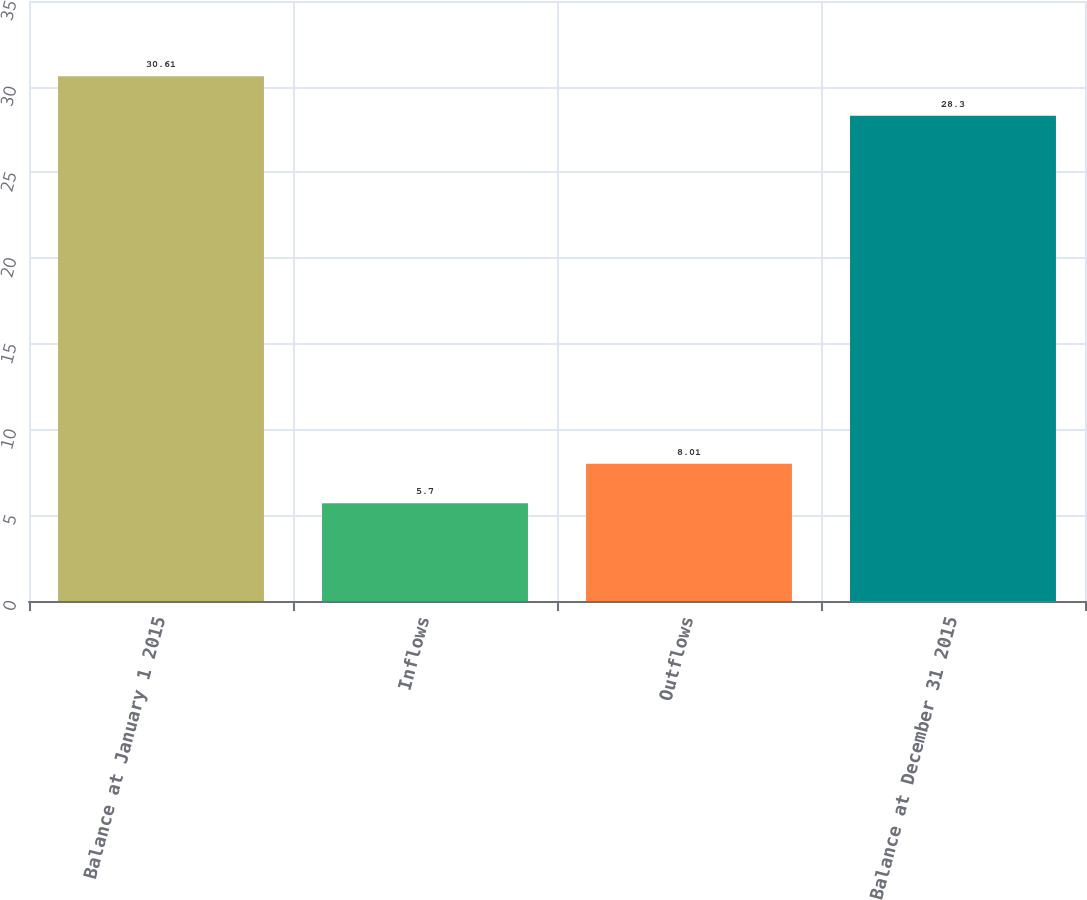Convert chart to OTSL. <chart><loc_0><loc_0><loc_500><loc_500><bar_chart><fcel>Balance at January 1 2015<fcel>Inflows<fcel>Outflows<fcel>Balance at December 31 2015<nl><fcel>30.61<fcel>5.7<fcel>8.01<fcel>28.3<nl></chart> 